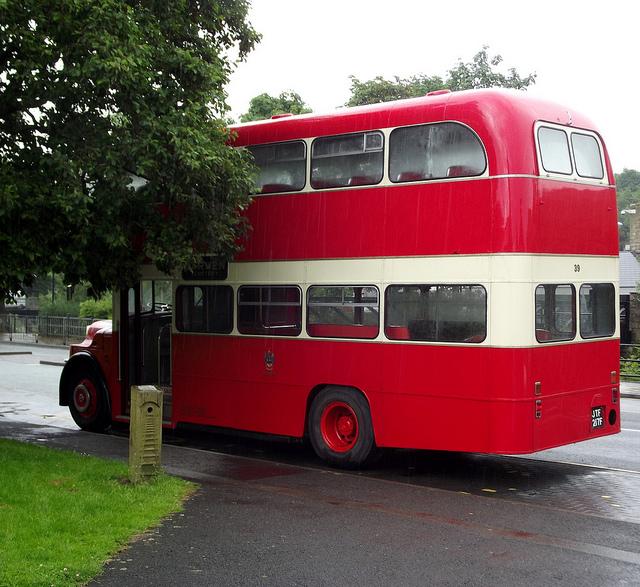How many decks is the bus?
Keep it brief. 2. What is the color of the bus?
Keep it brief. Red and white. Is there anyone in the bus?
Write a very short answer. No. 